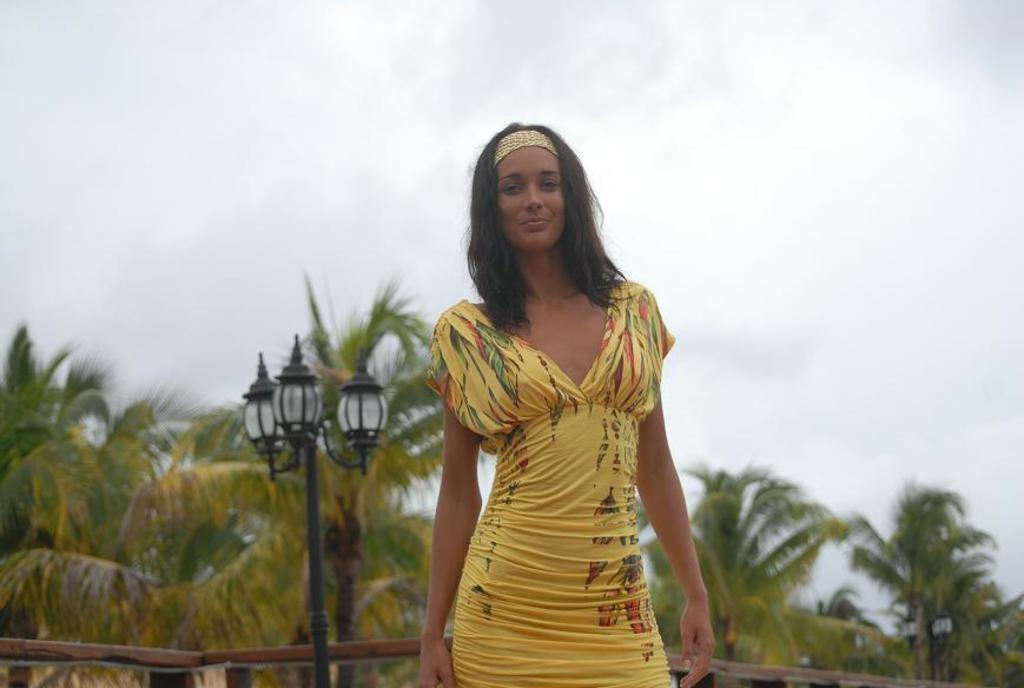Who is present in the image? There is a woman in the image. What is the woman doing in the image? The woman is standing and smiling. What can be seen in the background of the image? There are trees, a pole with lights, and the sky visible in the background of the image. What type of humor can be seen in the woman's expression in the image? The woman's expression is one of smiling, but there is no specific type of humor present in the image. Is there a chessboard visible in the image? No, there is no chessboard present in the image. 